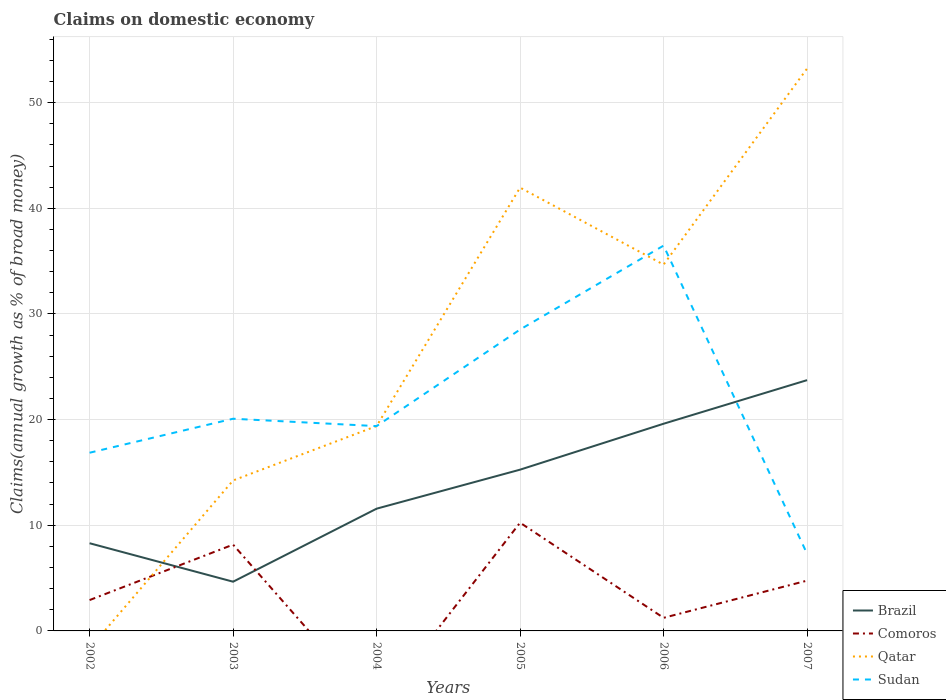Across all years, what is the maximum percentage of broad money claimed on domestic economy in Comoros?
Your answer should be very brief. 0. What is the total percentage of broad money claimed on domestic economy in Brazil in the graph?
Provide a short and direct response. -6.91. What is the difference between the highest and the second highest percentage of broad money claimed on domestic economy in Comoros?
Give a very brief answer. 10.24. What is the difference between the highest and the lowest percentage of broad money claimed on domestic economy in Sudan?
Your answer should be compact. 2. How many years are there in the graph?
Your answer should be very brief. 6. What is the difference between two consecutive major ticks on the Y-axis?
Your response must be concise. 10. Are the values on the major ticks of Y-axis written in scientific E-notation?
Your response must be concise. No. Does the graph contain grids?
Your answer should be very brief. Yes. Where does the legend appear in the graph?
Ensure brevity in your answer.  Bottom right. How are the legend labels stacked?
Give a very brief answer. Vertical. What is the title of the graph?
Provide a short and direct response. Claims on domestic economy. What is the label or title of the Y-axis?
Your response must be concise. Claims(annual growth as % of broad money). What is the Claims(annual growth as % of broad money) of Brazil in 2002?
Keep it short and to the point. 8.3. What is the Claims(annual growth as % of broad money) of Comoros in 2002?
Offer a very short reply. 2.92. What is the Claims(annual growth as % of broad money) in Qatar in 2002?
Your response must be concise. 0. What is the Claims(annual growth as % of broad money) of Sudan in 2002?
Your answer should be compact. 16.86. What is the Claims(annual growth as % of broad money) of Brazil in 2003?
Provide a short and direct response. 4.66. What is the Claims(annual growth as % of broad money) of Comoros in 2003?
Ensure brevity in your answer.  8.17. What is the Claims(annual growth as % of broad money) of Qatar in 2003?
Provide a short and direct response. 14.24. What is the Claims(annual growth as % of broad money) in Sudan in 2003?
Offer a terse response. 20.08. What is the Claims(annual growth as % of broad money) in Brazil in 2004?
Your answer should be compact. 11.57. What is the Claims(annual growth as % of broad money) in Qatar in 2004?
Provide a succinct answer. 19.39. What is the Claims(annual growth as % of broad money) in Sudan in 2004?
Offer a very short reply. 19.38. What is the Claims(annual growth as % of broad money) in Brazil in 2005?
Offer a very short reply. 15.26. What is the Claims(annual growth as % of broad money) of Comoros in 2005?
Your answer should be compact. 10.24. What is the Claims(annual growth as % of broad money) in Qatar in 2005?
Offer a very short reply. 41.96. What is the Claims(annual growth as % of broad money) of Sudan in 2005?
Your answer should be compact. 28.52. What is the Claims(annual growth as % of broad money) of Brazil in 2006?
Provide a short and direct response. 19.61. What is the Claims(annual growth as % of broad money) of Comoros in 2006?
Give a very brief answer. 1.24. What is the Claims(annual growth as % of broad money) in Qatar in 2006?
Give a very brief answer. 34.67. What is the Claims(annual growth as % of broad money) of Sudan in 2006?
Provide a succinct answer. 36.47. What is the Claims(annual growth as % of broad money) in Brazil in 2007?
Offer a very short reply. 23.73. What is the Claims(annual growth as % of broad money) of Comoros in 2007?
Your response must be concise. 4.76. What is the Claims(annual growth as % of broad money) in Qatar in 2007?
Your answer should be very brief. 53.22. What is the Claims(annual growth as % of broad money) in Sudan in 2007?
Ensure brevity in your answer.  7.3. Across all years, what is the maximum Claims(annual growth as % of broad money) in Brazil?
Offer a terse response. 23.73. Across all years, what is the maximum Claims(annual growth as % of broad money) in Comoros?
Your answer should be very brief. 10.24. Across all years, what is the maximum Claims(annual growth as % of broad money) of Qatar?
Give a very brief answer. 53.22. Across all years, what is the maximum Claims(annual growth as % of broad money) in Sudan?
Your answer should be very brief. 36.47. Across all years, what is the minimum Claims(annual growth as % of broad money) in Brazil?
Provide a succinct answer. 4.66. Across all years, what is the minimum Claims(annual growth as % of broad money) in Comoros?
Your response must be concise. 0. Across all years, what is the minimum Claims(annual growth as % of broad money) in Qatar?
Give a very brief answer. 0. Across all years, what is the minimum Claims(annual growth as % of broad money) in Sudan?
Your answer should be compact. 7.3. What is the total Claims(annual growth as % of broad money) of Brazil in the graph?
Provide a short and direct response. 83.13. What is the total Claims(annual growth as % of broad money) in Comoros in the graph?
Offer a very short reply. 27.33. What is the total Claims(annual growth as % of broad money) in Qatar in the graph?
Provide a short and direct response. 163.48. What is the total Claims(annual growth as % of broad money) in Sudan in the graph?
Offer a terse response. 128.62. What is the difference between the Claims(annual growth as % of broad money) of Brazil in 2002 and that in 2003?
Offer a terse response. 3.64. What is the difference between the Claims(annual growth as % of broad money) of Comoros in 2002 and that in 2003?
Make the answer very short. -5.25. What is the difference between the Claims(annual growth as % of broad money) of Sudan in 2002 and that in 2003?
Give a very brief answer. -3.22. What is the difference between the Claims(annual growth as % of broad money) of Brazil in 2002 and that in 2004?
Offer a very short reply. -3.27. What is the difference between the Claims(annual growth as % of broad money) of Sudan in 2002 and that in 2004?
Ensure brevity in your answer.  -2.52. What is the difference between the Claims(annual growth as % of broad money) of Brazil in 2002 and that in 2005?
Your answer should be compact. -6.96. What is the difference between the Claims(annual growth as % of broad money) of Comoros in 2002 and that in 2005?
Give a very brief answer. -7.32. What is the difference between the Claims(annual growth as % of broad money) in Sudan in 2002 and that in 2005?
Keep it short and to the point. -11.66. What is the difference between the Claims(annual growth as % of broad money) in Brazil in 2002 and that in 2006?
Offer a very short reply. -11.31. What is the difference between the Claims(annual growth as % of broad money) in Comoros in 2002 and that in 2006?
Offer a terse response. 1.68. What is the difference between the Claims(annual growth as % of broad money) of Sudan in 2002 and that in 2006?
Your answer should be very brief. -19.6. What is the difference between the Claims(annual growth as % of broad money) of Brazil in 2002 and that in 2007?
Make the answer very short. -15.44. What is the difference between the Claims(annual growth as % of broad money) of Comoros in 2002 and that in 2007?
Offer a very short reply. -1.84. What is the difference between the Claims(annual growth as % of broad money) in Sudan in 2002 and that in 2007?
Provide a succinct answer. 9.56. What is the difference between the Claims(annual growth as % of broad money) of Brazil in 2003 and that in 2004?
Give a very brief answer. -6.91. What is the difference between the Claims(annual growth as % of broad money) in Qatar in 2003 and that in 2004?
Offer a terse response. -5.15. What is the difference between the Claims(annual growth as % of broad money) of Sudan in 2003 and that in 2004?
Keep it short and to the point. 0.7. What is the difference between the Claims(annual growth as % of broad money) of Brazil in 2003 and that in 2005?
Your answer should be very brief. -10.6. What is the difference between the Claims(annual growth as % of broad money) in Comoros in 2003 and that in 2005?
Provide a short and direct response. -2.08. What is the difference between the Claims(annual growth as % of broad money) of Qatar in 2003 and that in 2005?
Provide a succinct answer. -27.72. What is the difference between the Claims(annual growth as % of broad money) of Sudan in 2003 and that in 2005?
Give a very brief answer. -8.44. What is the difference between the Claims(annual growth as % of broad money) of Brazil in 2003 and that in 2006?
Offer a very short reply. -14.95. What is the difference between the Claims(annual growth as % of broad money) in Comoros in 2003 and that in 2006?
Provide a short and direct response. 6.93. What is the difference between the Claims(annual growth as % of broad money) in Qatar in 2003 and that in 2006?
Provide a short and direct response. -20.43. What is the difference between the Claims(annual growth as % of broad money) in Sudan in 2003 and that in 2006?
Your answer should be compact. -16.38. What is the difference between the Claims(annual growth as % of broad money) of Brazil in 2003 and that in 2007?
Your answer should be very brief. -19.08. What is the difference between the Claims(annual growth as % of broad money) of Comoros in 2003 and that in 2007?
Your answer should be compact. 3.41. What is the difference between the Claims(annual growth as % of broad money) in Qatar in 2003 and that in 2007?
Your answer should be very brief. -38.98. What is the difference between the Claims(annual growth as % of broad money) in Sudan in 2003 and that in 2007?
Your answer should be very brief. 12.78. What is the difference between the Claims(annual growth as % of broad money) in Brazil in 2004 and that in 2005?
Offer a terse response. -3.69. What is the difference between the Claims(annual growth as % of broad money) in Qatar in 2004 and that in 2005?
Your answer should be very brief. -22.57. What is the difference between the Claims(annual growth as % of broad money) of Sudan in 2004 and that in 2005?
Offer a very short reply. -9.14. What is the difference between the Claims(annual growth as % of broad money) in Brazil in 2004 and that in 2006?
Your answer should be very brief. -8.04. What is the difference between the Claims(annual growth as % of broad money) in Qatar in 2004 and that in 2006?
Your response must be concise. -15.28. What is the difference between the Claims(annual growth as % of broad money) in Sudan in 2004 and that in 2006?
Keep it short and to the point. -17.08. What is the difference between the Claims(annual growth as % of broad money) in Brazil in 2004 and that in 2007?
Your response must be concise. -12.17. What is the difference between the Claims(annual growth as % of broad money) in Qatar in 2004 and that in 2007?
Your response must be concise. -33.84. What is the difference between the Claims(annual growth as % of broad money) in Sudan in 2004 and that in 2007?
Give a very brief answer. 12.08. What is the difference between the Claims(annual growth as % of broad money) in Brazil in 2005 and that in 2006?
Keep it short and to the point. -4.35. What is the difference between the Claims(annual growth as % of broad money) in Comoros in 2005 and that in 2006?
Offer a very short reply. 9. What is the difference between the Claims(annual growth as % of broad money) of Qatar in 2005 and that in 2006?
Your response must be concise. 7.29. What is the difference between the Claims(annual growth as % of broad money) of Sudan in 2005 and that in 2006?
Offer a terse response. -7.94. What is the difference between the Claims(annual growth as % of broad money) in Brazil in 2005 and that in 2007?
Your answer should be very brief. -8.47. What is the difference between the Claims(annual growth as % of broad money) in Comoros in 2005 and that in 2007?
Give a very brief answer. 5.48. What is the difference between the Claims(annual growth as % of broad money) in Qatar in 2005 and that in 2007?
Your answer should be compact. -11.27. What is the difference between the Claims(annual growth as % of broad money) in Sudan in 2005 and that in 2007?
Provide a short and direct response. 21.23. What is the difference between the Claims(annual growth as % of broad money) in Brazil in 2006 and that in 2007?
Make the answer very short. -4.13. What is the difference between the Claims(annual growth as % of broad money) in Comoros in 2006 and that in 2007?
Make the answer very short. -3.52. What is the difference between the Claims(annual growth as % of broad money) of Qatar in 2006 and that in 2007?
Provide a succinct answer. -18.56. What is the difference between the Claims(annual growth as % of broad money) in Sudan in 2006 and that in 2007?
Provide a succinct answer. 29.17. What is the difference between the Claims(annual growth as % of broad money) in Brazil in 2002 and the Claims(annual growth as % of broad money) in Comoros in 2003?
Your answer should be very brief. 0.13. What is the difference between the Claims(annual growth as % of broad money) of Brazil in 2002 and the Claims(annual growth as % of broad money) of Qatar in 2003?
Make the answer very short. -5.94. What is the difference between the Claims(annual growth as % of broad money) of Brazil in 2002 and the Claims(annual growth as % of broad money) of Sudan in 2003?
Make the answer very short. -11.78. What is the difference between the Claims(annual growth as % of broad money) in Comoros in 2002 and the Claims(annual growth as % of broad money) in Qatar in 2003?
Your answer should be compact. -11.32. What is the difference between the Claims(annual growth as % of broad money) of Comoros in 2002 and the Claims(annual growth as % of broad money) of Sudan in 2003?
Your answer should be very brief. -17.16. What is the difference between the Claims(annual growth as % of broad money) in Brazil in 2002 and the Claims(annual growth as % of broad money) in Qatar in 2004?
Your answer should be very brief. -11.09. What is the difference between the Claims(annual growth as % of broad money) of Brazil in 2002 and the Claims(annual growth as % of broad money) of Sudan in 2004?
Give a very brief answer. -11.08. What is the difference between the Claims(annual growth as % of broad money) of Comoros in 2002 and the Claims(annual growth as % of broad money) of Qatar in 2004?
Keep it short and to the point. -16.47. What is the difference between the Claims(annual growth as % of broad money) in Comoros in 2002 and the Claims(annual growth as % of broad money) in Sudan in 2004?
Your answer should be compact. -16.46. What is the difference between the Claims(annual growth as % of broad money) of Brazil in 2002 and the Claims(annual growth as % of broad money) of Comoros in 2005?
Keep it short and to the point. -1.94. What is the difference between the Claims(annual growth as % of broad money) in Brazil in 2002 and the Claims(annual growth as % of broad money) in Qatar in 2005?
Offer a terse response. -33.66. What is the difference between the Claims(annual growth as % of broad money) of Brazil in 2002 and the Claims(annual growth as % of broad money) of Sudan in 2005?
Offer a very short reply. -20.23. What is the difference between the Claims(annual growth as % of broad money) of Comoros in 2002 and the Claims(annual growth as % of broad money) of Qatar in 2005?
Give a very brief answer. -39.04. What is the difference between the Claims(annual growth as % of broad money) of Comoros in 2002 and the Claims(annual growth as % of broad money) of Sudan in 2005?
Keep it short and to the point. -25.6. What is the difference between the Claims(annual growth as % of broad money) in Brazil in 2002 and the Claims(annual growth as % of broad money) in Comoros in 2006?
Offer a terse response. 7.06. What is the difference between the Claims(annual growth as % of broad money) in Brazil in 2002 and the Claims(annual growth as % of broad money) in Qatar in 2006?
Offer a very short reply. -26.37. What is the difference between the Claims(annual growth as % of broad money) in Brazil in 2002 and the Claims(annual growth as % of broad money) in Sudan in 2006?
Your answer should be compact. -28.17. What is the difference between the Claims(annual growth as % of broad money) of Comoros in 2002 and the Claims(annual growth as % of broad money) of Qatar in 2006?
Make the answer very short. -31.75. What is the difference between the Claims(annual growth as % of broad money) of Comoros in 2002 and the Claims(annual growth as % of broad money) of Sudan in 2006?
Ensure brevity in your answer.  -33.55. What is the difference between the Claims(annual growth as % of broad money) of Brazil in 2002 and the Claims(annual growth as % of broad money) of Comoros in 2007?
Provide a succinct answer. 3.54. What is the difference between the Claims(annual growth as % of broad money) of Brazil in 2002 and the Claims(annual growth as % of broad money) of Qatar in 2007?
Keep it short and to the point. -44.93. What is the difference between the Claims(annual growth as % of broad money) in Comoros in 2002 and the Claims(annual growth as % of broad money) in Qatar in 2007?
Make the answer very short. -50.3. What is the difference between the Claims(annual growth as % of broad money) in Comoros in 2002 and the Claims(annual growth as % of broad money) in Sudan in 2007?
Offer a very short reply. -4.38. What is the difference between the Claims(annual growth as % of broad money) in Brazil in 2003 and the Claims(annual growth as % of broad money) in Qatar in 2004?
Your answer should be very brief. -14.73. What is the difference between the Claims(annual growth as % of broad money) of Brazil in 2003 and the Claims(annual growth as % of broad money) of Sudan in 2004?
Offer a terse response. -14.72. What is the difference between the Claims(annual growth as % of broad money) of Comoros in 2003 and the Claims(annual growth as % of broad money) of Qatar in 2004?
Provide a short and direct response. -11.22. What is the difference between the Claims(annual growth as % of broad money) in Comoros in 2003 and the Claims(annual growth as % of broad money) in Sudan in 2004?
Your answer should be very brief. -11.22. What is the difference between the Claims(annual growth as % of broad money) in Qatar in 2003 and the Claims(annual growth as % of broad money) in Sudan in 2004?
Your answer should be compact. -5.14. What is the difference between the Claims(annual growth as % of broad money) of Brazil in 2003 and the Claims(annual growth as % of broad money) of Comoros in 2005?
Your response must be concise. -5.59. What is the difference between the Claims(annual growth as % of broad money) in Brazil in 2003 and the Claims(annual growth as % of broad money) in Qatar in 2005?
Your response must be concise. -37.3. What is the difference between the Claims(annual growth as % of broad money) in Brazil in 2003 and the Claims(annual growth as % of broad money) in Sudan in 2005?
Offer a very short reply. -23.87. What is the difference between the Claims(annual growth as % of broad money) in Comoros in 2003 and the Claims(annual growth as % of broad money) in Qatar in 2005?
Your answer should be very brief. -33.79. What is the difference between the Claims(annual growth as % of broad money) in Comoros in 2003 and the Claims(annual growth as % of broad money) in Sudan in 2005?
Offer a terse response. -20.36. What is the difference between the Claims(annual growth as % of broad money) of Qatar in 2003 and the Claims(annual growth as % of broad money) of Sudan in 2005?
Provide a short and direct response. -14.28. What is the difference between the Claims(annual growth as % of broad money) of Brazil in 2003 and the Claims(annual growth as % of broad money) of Comoros in 2006?
Keep it short and to the point. 3.42. What is the difference between the Claims(annual growth as % of broad money) in Brazil in 2003 and the Claims(annual growth as % of broad money) in Qatar in 2006?
Your answer should be very brief. -30.01. What is the difference between the Claims(annual growth as % of broad money) in Brazil in 2003 and the Claims(annual growth as % of broad money) in Sudan in 2006?
Make the answer very short. -31.81. What is the difference between the Claims(annual growth as % of broad money) in Comoros in 2003 and the Claims(annual growth as % of broad money) in Qatar in 2006?
Your answer should be compact. -26.5. What is the difference between the Claims(annual growth as % of broad money) in Comoros in 2003 and the Claims(annual growth as % of broad money) in Sudan in 2006?
Provide a succinct answer. -28.3. What is the difference between the Claims(annual growth as % of broad money) of Qatar in 2003 and the Claims(annual growth as % of broad money) of Sudan in 2006?
Your answer should be very brief. -22.22. What is the difference between the Claims(annual growth as % of broad money) of Brazil in 2003 and the Claims(annual growth as % of broad money) of Comoros in 2007?
Your answer should be very brief. -0.1. What is the difference between the Claims(annual growth as % of broad money) of Brazil in 2003 and the Claims(annual growth as % of broad money) of Qatar in 2007?
Your answer should be compact. -48.57. What is the difference between the Claims(annual growth as % of broad money) in Brazil in 2003 and the Claims(annual growth as % of broad money) in Sudan in 2007?
Offer a terse response. -2.64. What is the difference between the Claims(annual growth as % of broad money) in Comoros in 2003 and the Claims(annual growth as % of broad money) in Qatar in 2007?
Your response must be concise. -45.06. What is the difference between the Claims(annual growth as % of broad money) of Comoros in 2003 and the Claims(annual growth as % of broad money) of Sudan in 2007?
Offer a terse response. 0.87. What is the difference between the Claims(annual growth as % of broad money) of Qatar in 2003 and the Claims(annual growth as % of broad money) of Sudan in 2007?
Your answer should be very brief. 6.94. What is the difference between the Claims(annual growth as % of broad money) in Brazil in 2004 and the Claims(annual growth as % of broad money) in Comoros in 2005?
Offer a terse response. 1.33. What is the difference between the Claims(annual growth as % of broad money) in Brazil in 2004 and the Claims(annual growth as % of broad money) in Qatar in 2005?
Offer a terse response. -30.39. What is the difference between the Claims(annual growth as % of broad money) of Brazil in 2004 and the Claims(annual growth as % of broad money) of Sudan in 2005?
Your answer should be very brief. -16.96. What is the difference between the Claims(annual growth as % of broad money) in Qatar in 2004 and the Claims(annual growth as % of broad money) in Sudan in 2005?
Offer a very short reply. -9.14. What is the difference between the Claims(annual growth as % of broad money) in Brazil in 2004 and the Claims(annual growth as % of broad money) in Comoros in 2006?
Give a very brief answer. 10.33. What is the difference between the Claims(annual growth as % of broad money) in Brazil in 2004 and the Claims(annual growth as % of broad money) in Qatar in 2006?
Provide a short and direct response. -23.1. What is the difference between the Claims(annual growth as % of broad money) in Brazil in 2004 and the Claims(annual growth as % of broad money) in Sudan in 2006?
Offer a very short reply. -24.9. What is the difference between the Claims(annual growth as % of broad money) in Qatar in 2004 and the Claims(annual growth as % of broad money) in Sudan in 2006?
Provide a succinct answer. -17.08. What is the difference between the Claims(annual growth as % of broad money) in Brazil in 2004 and the Claims(annual growth as % of broad money) in Comoros in 2007?
Keep it short and to the point. 6.81. What is the difference between the Claims(annual growth as % of broad money) in Brazil in 2004 and the Claims(annual growth as % of broad money) in Qatar in 2007?
Give a very brief answer. -41.66. What is the difference between the Claims(annual growth as % of broad money) in Brazil in 2004 and the Claims(annual growth as % of broad money) in Sudan in 2007?
Give a very brief answer. 4.27. What is the difference between the Claims(annual growth as % of broad money) of Qatar in 2004 and the Claims(annual growth as % of broad money) of Sudan in 2007?
Give a very brief answer. 12.09. What is the difference between the Claims(annual growth as % of broad money) in Brazil in 2005 and the Claims(annual growth as % of broad money) in Comoros in 2006?
Offer a very short reply. 14.02. What is the difference between the Claims(annual growth as % of broad money) in Brazil in 2005 and the Claims(annual growth as % of broad money) in Qatar in 2006?
Your answer should be compact. -19.41. What is the difference between the Claims(annual growth as % of broad money) of Brazil in 2005 and the Claims(annual growth as % of broad money) of Sudan in 2006?
Your answer should be very brief. -21.2. What is the difference between the Claims(annual growth as % of broad money) of Comoros in 2005 and the Claims(annual growth as % of broad money) of Qatar in 2006?
Provide a short and direct response. -24.42. What is the difference between the Claims(annual growth as % of broad money) of Comoros in 2005 and the Claims(annual growth as % of broad money) of Sudan in 2006?
Your response must be concise. -26.22. What is the difference between the Claims(annual growth as % of broad money) of Qatar in 2005 and the Claims(annual growth as % of broad money) of Sudan in 2006?
Offer a terse response. 5.49. What is the difference between the Claims(annual growth as % of broad money) in Brazil in 2005 and the Claims(annual growth as % of broad money) in Comoros in 2007?
Give a very brief answer. 10.5. What is the difference between the Claims(annual growth as % of broad money) of Brazil in 2005 and the Claims(annual growth as % of broad money) of Qatar in 2007?
Give a very brief answer. -37.96. What is the difference between the Claims(annual growth as % of broad money) in Brazil in 2005 and the Claims(annual growth as % of broad money) in Sudan in 2007?
Your answer should be very brief. 7.96. What is the difference between the Claims(annual growth as % of broad money) in Comoros in 2005 and the Claims(annual growth as % of broad money) in Qatar in 2007?
Your response must be concise. -42.98. What is the difference between the Claims(annual growth as % of broad money) of Comoros in 2005 and the Claims(annual growth as % of broad money) of Sudan in 2007?
Keep it short and to the point. 2.94. What is the difference between the Claims(annual growth as % of broad money) in Qatar in 2005 and the Claims(annual growth as % of broad money) in Sudan in 2007?
Your answer should be compact. 34.66. What is the difference between the Claims(annual growth as % of broad money) in Brazil in 2006 and the Claims(annual growth as % of broad money) in Comoros in 2007?
Your answer should be compact. 14.85. What is the difference between the Claims(annual growth as % of broad money) of Brazil in 2006 and the Claims(annual growth as % of broad money) of Qatar in 2007?
Keep it short and to the point. -33.62. What is the difference between the Claims(annual growth as % of broad money) of Brazil in 2006 and the Claims(annual growth as % of broad money) of Sudan in 2007?
Your answer should be very brief. 12.31. What is the difference between the Claims(annual growth as % of broad money) of Comoros in 2006 and the Claims(annual growth as % of broad money) of Qatar in 2007?
Make the answer very short. -51.99. What is the difference between the Claims(annual growth as % of broad money) of Comoros in 2006 and the Claims(annual growth as % of broad money) of Sudan in 2007?
Offer a terse response. -6.06. What is the difference between the Claims(annual growth as % of broad money) of Qatar in 2006 and the Claims(annual growth as % of broad money) of Sudan in 2007?
Provide a succinct answer. 27.37. What is the average Claims(annual growth as % of broad money) of Brazil per year?
Your answer should be very brief. 13.86. What is the average Claims(annual growth as % of broad money) in Comoros per year?
Offer a very short reply. 4.55. What is the average Claims(annual growth as % of broad money) of Qatar per year?
Provide a short and direct response. 27.25. What is the average Claims(annual growth as % of broad money) in Sudan per year?
Give a very brief answer. 21.44. In the year 2002, what is the difference between the Claims(annual growth as % of broad money) in Brazil and Claims(annual growth as % of broad money) in Comoros?
Your answer should be very brief. 5.38. In the year 2002, what is the difference between the Claims(annual growth as % of broad money) of Brazil and Claims(annual growth as % of broad money) of Sudan?
Your response must be concise. -8.56. In the year 2002, what is the difference between the Claims(annual growth as % of broad money) in Comoros and Claims(annual growth as % of broad money) in Sudan?
Offer a terse response. -13.94. In the year 2003, what is the difference between the Claims(annual growth as % of broad money) in Brazil and Claims(annual growth as % of broad money) in Comoros?
Give a very brief answer. -3.51. In the year 2003, what is the difference between the Claims(annual growth as % of broad money) in Brazil and Claims(annual growth as % of broad money) in Qatar?
Give a very brief answer. -9.58. In the year 2003, what is the difference between the Claims(annual growth as % of broad money) of Brazil and Claims(annual growth as % of broad money) of Sudan?
Ensure brevity in your answer.  -15.42. In the year 2003, what is the difference between the Claims(annual growth as % of broad money) of Comoros and Claims(annual growth as % of broad money) of Qatar?
Keep it short and to the point. -6.07. In the year 2003, what is the difference between the Claims(annual growth as % of broad money) in Comoros and Claims(annual growth as % of broad money) in Sudan?
Your answer should be compact. -11.92. In the year 2003, what is the difference between the Claims(annual growth as % of broad money) of Qatar and Claims(annual growth as % of broad money) of Sudan?
Give a very brief answer. -5.84. In the year 2004, what is the difference between the Claims(annual growth as % of broad money) in Brazil and Claims(annual growth as % of broad money) in Qatar?
Keep it short and to the point. -7.82. In the year 2004, what is the difference between the Claims(annual growth as % of broad money) in Brazil and Claims(annual growth as % of broad money) in Sudan?
Offer a very short reply. -7.81. In the year 2004, what is the difference between the Claims(annual growth as % of broad money) in Qatar and Claims(annual growth as % of broad money) in Sudan?
Provide a short and direct response. 0.01. In the year 2005, what is the difference between the Claims(annual growth as % of broad money) of Brazil and Claims(annual growth as % of broad money) of Comoros?
Offer a terse response. 5.02. In the year 2005, what is the difference between the Claims(annual growth as % of broad money) in Brazil and Claims(annual growth as % of broad money) in Qatar?
Provide a succinct answer. -26.69. In the year 2005, what is the difference between the Claims(annual growth as % of broad money) in Brazil and Claims(annual growth as % of broad money) in Sudan?
Provide a short and direct response. -13.26. In the year 2005, what is the difference between the Claims(annual growth as % of broad money) in Comoros and Claims(annual growth as % of broad money) in Qatar?
Your answer should be compact. -31.71. In the year 2005, what is the difference between the Claims(annual growth as % of broad money) in Comoros and Claims(annual growth as % of broad money) in Sudan?
Make the answer very short. -18.28. In the year 2005, what is the difference between the Claims(annual growth as % of broad money) in Qatar and Claims(annual growth as % of broad money) in Sudan?
Your answer should be compact. 13.43. In the year 2006, what is the difference between the Claims(annual growth as % of broad money) in Brazil and Claims(annual growth as % of broad money) in Comoros?
Your response must be concise. 18.37. In the year 2006, what is the difference between the Claims(annual growth as % of broad money) in Brazil and Claims(annual growth as % of broad money) in Qatar?
Keep it short and to the point. -15.06. In the year 2006, what is the difference between the Claims(annual growth as % of broad money) of Brazil and Claims(annual growth as % of broad money) of Sudan?
Offer a terse response. -16.86. In the year 2006, what is the difference between the Claims(annual growth as % of broad money) of Comoros and Claims(annual growth as % of broad money) of Qatar?
Offer a very short reply. -33.43. In the year 2006, what is the difference between the Claims(annual growth as % of broad money) of Comoros and Claims(annual growth as % of broad money) of Sudan?
Offer a terse response. -35.23. In the year 2006, what is the difference between the Claims(annual growth as % of broad money) in Qatar and Claims(annual growth as % of broad money) in Sudan?
Keep it short and to the point. -1.8. In the year 2007, what is the difference between the Claims(annual growth as % of broad money) of Brazil and Claims(annual growth as % of broad money) of Comoros?
Give a very brief answer. 18.97. In the year 2007, what is the difference between the Claims(annual growth as % of broad money) of Brazil and Claims(annual growth as % of broad money) of Qatar?
Keep it short and to the point. -29.49. In the year 2007, what is the difference between the Claims(annual growth as % of broad money) in Brazil and Claims(annual growth as % of broad money) in Sudan?
Your answer should be very brief. 16.44. In the year 2007, what is the difference between the Claims(annual growth as % of broad money) of Comoros and Claims(annual growth as % of broad money) of Qatar?
Make the answer very short. -48.46. In the year 2007, what is the difference between the Claims(annual growth as % of broad money) in Comoros and Claims(annual growth as % of broad money) in Sudan?
Offer a very short reply. -2.54. In the year 2007, what is the difference between the Claims(annual growth as % of broad money) in Qatar and Claims(annual growth as % of broad money) in Sudan?
Your answer should be very brief. 45.93. What is the ratio of the Claims(annual growth as % of broad money) in Brazil in 2002 to that in 2003?
Your answer should be very brief. 1.78. What is the ratio of the Claims(annual growth as % of broad money) of Comoros in 2002 to that in 2003?
Provide a succinct answer. 0.36. What is the ratio of the Claims(annual growth as % of broad money) in Sudan in 2002 to that in 2003?
Provide a succinct answer. 0.84. What is the ratio of the Claims(annual growth as % of broad money) of Brazil in 2002 to that in 2004?
Keep it short and to the point. 0.72. What is the ratio of the Claims(annual growth as % of broad money) of Sudan in 2002 to that in 2004?
Offer a terse response. 0.87. What is the ratio of the Claims(annual growth as % of broad money) of Brazil in 2002 to that in 2005?
Your answer should be compact. 0.54. What is the ratio of the Claims(annual growth as % of broad money) in Comoros in 2002 to that in 2005?
Provide a succinct answer. 0.29. What is the ratio of the Claims(annual growth as % of broad money) in Sudan in 2002 to that in 2005?
Provide a short and direct response. 0.59. What is the ratio of the Claims(annual growth as % of broad money) in Brazil in 2002 to that in 2006?
Your answer should be very brief. 0.42. What is the ratio of the Claims(annual growth as % of broad money) of Comoros in 2002 to that in 2006?
Ensure brevity in your answer.  2.36. What is the ratio of the Claims(annual growth as % of broad money) in Sudan in 2002 to that in 2006?
Your answer should be compact. 0.46. What is the ratio of the Claims(annual growth as % of broad money) in Brazil in 2002 to that in 2007?
Keep it short and to the point. 0.35. What is the ratio of the Claims(annual growth as % of broad money) of Comoros in 2002 to that in 2007?
Offer a very short reply. 0.61. What is the ratio of the Claims(annual growth as % of broad money) in Sudan in 2002 to that in 2007?
Provide a short and direct response. 2.31. What is the ratio of the Claims(annual growth as % of broad money) of Brazil in 2003 to that in 2004?
Ensure brevity in your answer.  0.4. What is the ratio of the Claims(annual growth as % of broad money) of Qatar in 2003 to that in 2004?
Your answer should be very brief. 0.73. What is the ratio of the Claims(annual growth as % of broad money) of Sudan in 2003 to that in 2004?
Offer a terse response. 1.04. What is the ratio of the Claims(annual growth as % of broad money) in Brazil in 2003 to that in 2005?
Your response must be concise. 0.31. What is the ratio of the Claims(annual growth as % of broad money) in Comoros in 2003 to that in 2005?
Keep it short and to the point. 0.8. What is the ratio of the Claims(annual growth as % of broad money) of Qatar in 2003 to that in 2005?
Provide a succinct answer. 0.34. What is the ratio of the Claims(annual growth as % of broad money) in Sudan in 2003 to that in 2005?
Provide a succinct answer. 0.7. What is the ratio of the Claims(annual growth as % of broad money) of Brazil in 2003 to that in 2006?
Provide a short and direct response. 0.24. What is the ratio of the Claims(annual growth as % of broad money) of Comoros in 2003 to that in 2006?
Keep it short and to the point. 6.59. What is the ratio of the Claims(annual growth as % of broad money) of Qatar in 2003 to that in 2006?
Offer a terse response. 0.41. What is the ratio of the Claims(annual growth as % of broad money) in Sudan in 2003 to that in 2006?
Provide a succinct answer. 0.55. What is the ratio of the Claims(annual growth as % of broad money) in Brazil in 2003 to that in 2007?
Offer a terse response. 0.2. What is the ratio of the Claims(annual growth as % of broad money) of Comoros in 2003 to that in 2007?
Your response must be concise. 1.72. What is the ratio of the Claims(annual growth as % of broad money) in Qatar in 2003 to that in 2007?
Provide a short and direct response. 0.27. What is the ratio of the Claims(annual growth as % of broad money) of Sudan in 2003 to that in 2007?
Provide a short and direct response. 2.75. What is the ratio of the Claims(annual growth as % of broad money) in Brazil in 2004 to that in 2005?
Make the answer very short. 0.76. What is the ratio of the Claims(annual growth as % of broad money) of Qatar in 2004 to that in 2005?
Make the answer very short. 0.46. What is the ratio of the Claims(annual growth as % of broad money) in Sudan in 2004 to that in 2005?
Provide a succinct answer. 0.68. What is the ratio of the Claims(annual growth as % of broad money) of Brazil in 2004 to that in 2006?
Your answer should be compact. 0.59. What is the ratio of the Claims(annual growth as % of broad money) of Qatar in 2004 to that in 2006?
Give a very brief answer. 0.56. What is the ratio of the Claims(annual growth as % of broad money) in Sudan in 2004 to that in 2006?
Your answer should be compact. 0.53. What is the ratio of the Claims(annual growth as % of broad money) in Brazil in 2004 to that in 2007?
Provide a short and direct response. 0.49. What is the ratio of the Claims(annual growth as % of broad money) in Qatar in 2004 to that in 2007?
Ensure brevity in your answer.  0.36. What is the ratio of the Claims(annual growth as % of broad money) of Sudan in 2004 to that in 2007?
Make the answer very short. 2.66. What is the ratio of the Claims(annual growth as % of broad money) of Brazil in 2005 to that in 2006?
Your response must be concise. 0.78. What is the ratio of the Claims(annual growth as % of broad money) in Comoros in 2005 to that in 2006?
Keep it short and to the point. 8.27. What is the ratio of the Claims(annual growth as % of broad money) of Qatar in 2005 to that in 2006?
Offer a very short reply. 1.21. What is the ratio of the Claims(annual growth as % of broad money) in Sudan in 2005 to that in 2006?
Your answer should be very brief. 0.78. What is the ratio of the Claims(annual growth as % of broad money) in Brazil in 2005 to that in 2007?
Your answer should be compact. 0.64. What is the ratio of the Claims(annual growth as % of broad money) of Comoros in 2005 to that in 2007?
Your response must be concise. 2.15. What is the ratio of the Claims(annual growth as % of broad money) of Qatar in 2005 to that in 2007?
Offer a terse response. 0.79. What is the ratio of the Claims(annual growth as % of broad money) of Sudan in 2005 to that in 2007?
Make the answer very short. 3.91. What is the ratio of the Claims(annual growth as % of broad money) in Brazil in 2006 to that in 2007?
Offer a very short reply. 0.83. What is the ratio of the Claims(annual growth as % of broad money) of Comoros in 2006 to that in 2007?
Keep it short and to the point. 0.26. What is the ratio of the Claims(annual growth as % of broad money) of Qatar in 2006 to that in 2007?
Your answer should be compact. 0.65. What is the ratio of the Claims(annual growth as % of broad money) in Sudan in 2006 to that in 2007?
Ensure brevity in your answer.  5. What is the difference between the highest and the second highest Claims(annual growth as % of broad money) of Brazil?
Your answer should be very brief. 4.13. What is the difference between the highest and the second highest Claims(annual growth as % of broad money) of Comoros?
Your answer should be very brief. 2.08. What is the difference between the highest and the second highest Claims(annual growth as % of broad money) of Qatar?
Keep it short and to the point. 11.27. What is the difference between the highest and the second highest Claims(annual growth as % of broad money) of Sudan?
Provide a succinct answer. 7.94. What is the difference between the highest and the lowest Claims(annual growth as % of broad money) in Brazil?
Make the answer very short. 19.08. What is the difference between the highest and the lowest Claims(annual growth as % of broad money) in Comoros?
Offer a very short reply. 10.24. What is the difference between the highest and the lowest Claims(annual growth as % of broad money) in Qatar?
Give a very brief answer. 53.22. What is the difference between the highest and the lowest Claims(annual growth as % of broad money) of Sudan?
Offer a terse response. 29.17. 